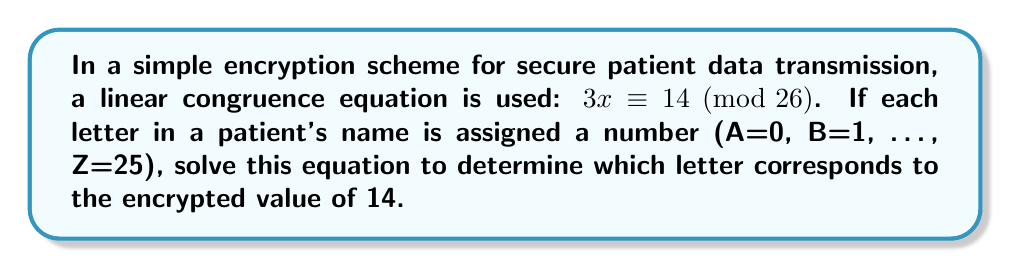Give your solution to this math problem. To solve the linear congruence equation $3x \equiv 14 \pmod{26}$, we follow these steps:

1) First, we need to find the modular multiplicative inverse of 3 modulo 26. Let's call this inverse $y$. It satisfies:

   $3y \equiv 1 \pmod{26}$

2) We can find $y$ by trying values or using the extended Euclidean algorithm. In this case, $y = 9$ because:

   $3 \cdot 9 = 27 \equiv 1 \pmod{26}$

3) Now, multiply both sides of the original congruence by $y$:

   $y(3x) \equiv y(14) \pmod{26}$

4) Using the property of modular arithmetic:

   $(y \cdot 3)x \equiv 14y \pmod{26}$

5) Simplify:

   $x \equiv 14 \cdot 9 \pmod{26}$
   $x \equiv 126 \pmod{26}$

6) Simplify further:

   $x \equiv 22 \pmod{26}$

7) Since we're using A=0, B=1, ..., Z=25, the number 22 corresponds to the letter W.

Therefore, the encrypted value of 14 corresponds to the letter W in the patient's name.
Answer: W 